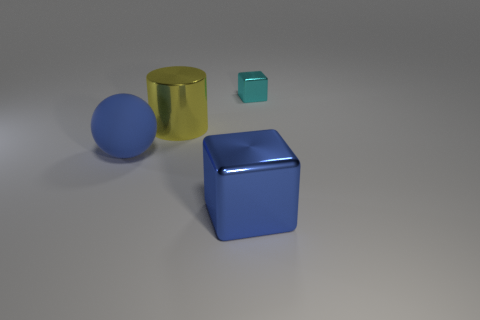Is there anything else that has the same material as the sphere?
Ensure brevity in your answer.  No. There is a metal object on the left side of the big block; is it the same shape as the small cyan shiny thing behind the blue rubber thing?
Your answer should be compact. No. How many other objects are the same color as the large matte sphere?
Keep it short and to the point. 1. Does the cube that is left of the tiny metal block have the same material as the big yellow object that is to the right of the ball?
Your answer should be compact. Yes. Are there an equal number of large cubes to the right of the big blue metal thing and big shiny objects behind the large cylinder?
Keep it short and to the point. Yes. What is the material of the small block behind the cylinder?
Make the answer very short. Metal. Are there any other things that have the same size as the blue metal thing?
Offer a terse response. Yes. Is the number of tiny red rubber things less than the number of tiny cyan cubes?
Offer a terse response. Yes. What is the shape of the metallic object that is both right of the large yellow shiny cylinder and behind the blue metallic thing?
Your answer should be compact. Cube. What number of matte spheres are there?
Your answer should be very brief. 1. 